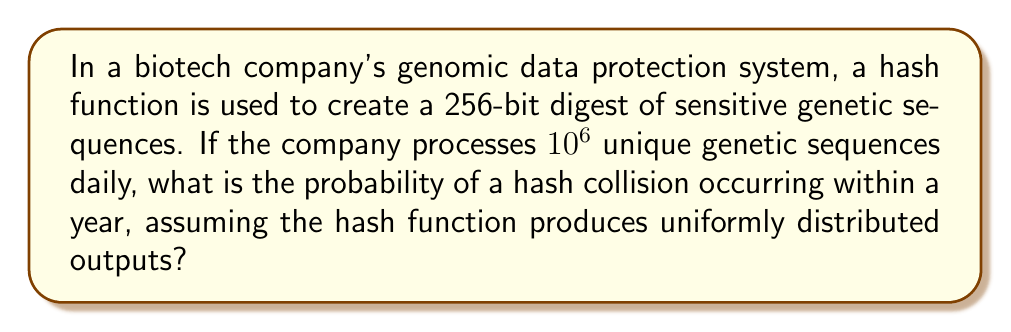Help me with this question. To solve this problem, we'll use the birthday paradox approach:

1) First, calculate the number of unique genetic sequences processed in a year:
   $365 \text{ days} \times 10^6 \text{ sequences/day} = 3.65 \times 10^8 \text{ sequences/year}$

2) The number of possible hash outputs is $2^{256}$, as it's a 256-bit hash.

3) The probability of no collisions after $n$ inputs is approximately:

   $$ P(\text{no collision}) \approx e^{-\frac{n^2}{2m}} $$

   Where $n$ is the number of inputs and $m$ is the number of possible hash values.

4) In our case:
   $n = 3.65 \times 10^8$
   $m = 2^{256}$

5) Substituting these values:

   $$ P(\text{no collision}) \approx e^{-\frac{(3.65 \times 10^8)^2}{2 \times 2^{256}}} $$

6) Simplify:
   $$ P(\text{no collision}) \approx e^{-\frac{1.33225 \times 10^{17}}{2 \times 1.1579 \times 10^{77}}} \approx e^{-5.75 \times 10^{-61}} $$

7) The probability of at least one collision is:
   $$ P(\text{collision}) = 1 - P(\text{no collision}) \approx 1 - e^{-5.75 \times 10^{-61}} \approx 5.75 \times 10^{-61} $$
Answer: $5.75 \times 10^{-61}$ 